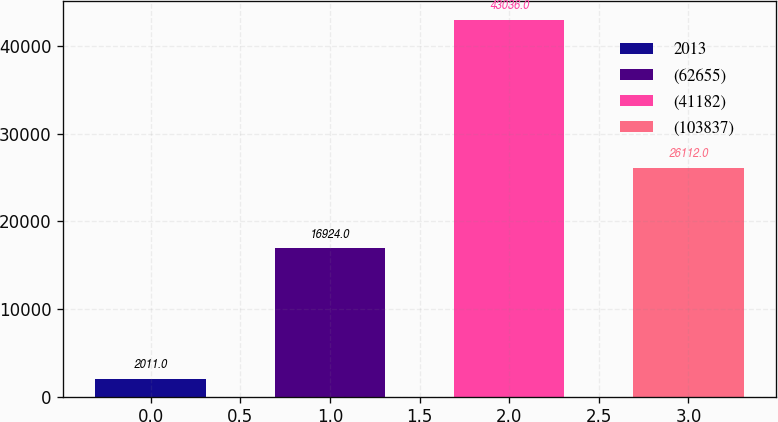Convert chart to OTSL. <chart><loc_0><loc_0><loc_500><loc_500><bar_chart><fcel>2013<fcel>(62655)<fcel>(41182)<fcel>(103837)<nl><fcel>2011<fcel>16924<fcel>43036<fcel>26112<nl></chart> 